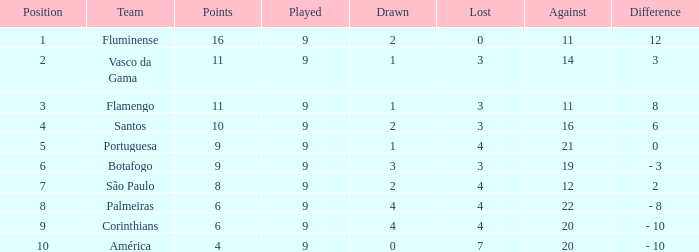Which average Played has a Drawn smaller than 1, and Points larger than 4? None. 